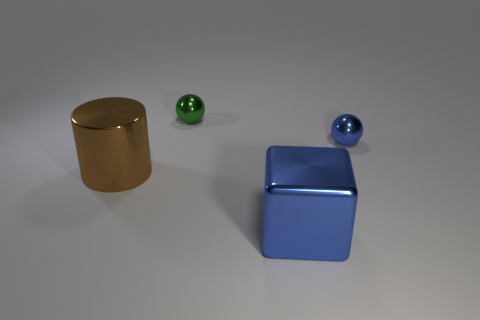Add 1 tiny blue metal balls. How many objects exist? 5 Subtract all green spheres. How many spheres are left? 1 Subtract all cylinders. How many objects are left? 3 Subtract 1 spheres. How many spheres are left? 1 Subtract all gray cylinders. Subtract all red cubes. How many cylinders are left? 1 Subtract all big brown objects. Subtract all brown cylinders. How many objects are left? 2 Add 3 metal blocks. How many metal blocks are left? 4 Add 4 shiny blocks. How many shiny blocks exist? 5 Subtract 0 yellow spheres. How many objects are left? 4 